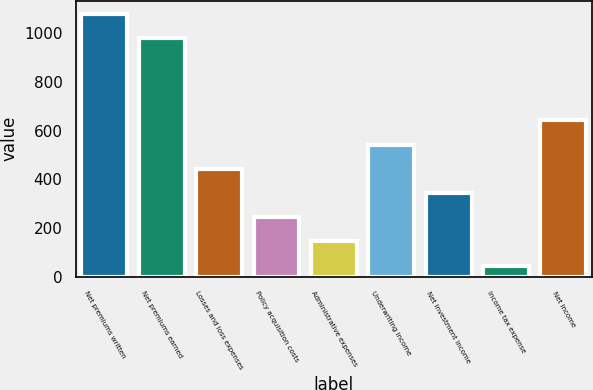Convert chart. <chart><loc_0><loc_0><loc_500><loc_500><bar_chart><fcel>Net premiums written<fcel>Net premiums earned<fcel>Losses and loss expenses<fcel>Policy acquisition costs<fcel>Administrative expenses<fcel>Underwriting income<fcel>Net investment income<fcel>Income tax expense<fcel>Net income<nl><fcel>1078.2<fcel>979<fcel>442.8<fcel>244.4<fcel>145.2<fcel>542<fcel>343.6<fcel>46<fcel>641.2<nl></chart> 